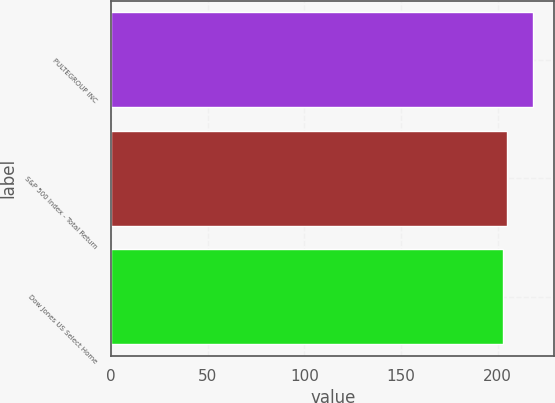Convert chart to OTSL. <chart><loc_0><loc_0><loc_500><loc_500><bar_chart><fcel>PULTEGROUP INC<fcel>S&P 500 Index - Total Return<fcel>Dow Jones US Select Home<nl><fcel>218.5<fcel>205.14<fcel>202.92<nl></chart> 